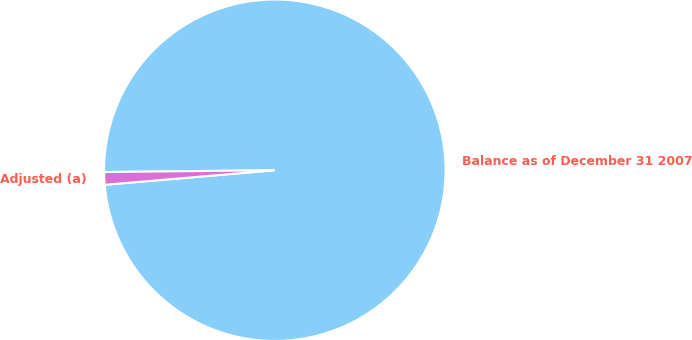Convert chart to OTSL. <chart><loc_0><loc_0><loc_500><loc_500><pie_chart><fcel>Balance as of December 31 2007<fcel>Adjusted (a)<nl><fcel>98.81%<fcel>1.19%<nl></chart> 